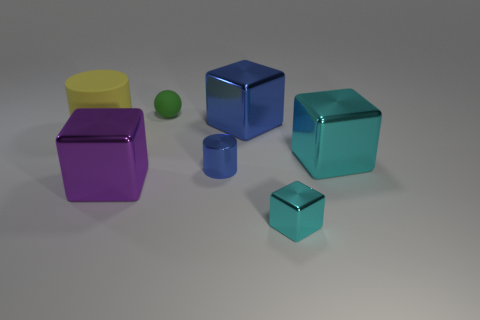Subtract all cyan cylinders. How many cyan blocks are left? 2 Add 3 purple metallic cubes. How many objects exist? 10 Subtract all big purple shiny cubes. How many cubes are left? 3 Subtract all cylinders. How many objects are left? 5 Add 3 big objects. How many big objects are left? 7 Add 1 blue metal objects. How many blue metal objects exist? 3 Subtract all purple blocks. How many blocks are left? 3 Subtract 0 gray cylinders. How many objects are left? 7 Subtract all purple cubes. Subtract all cyan cylinders. How many cubes are left? 3 Subtract all big cyan objects. Subtract all small shiny blocks. How many objects are left? 5 